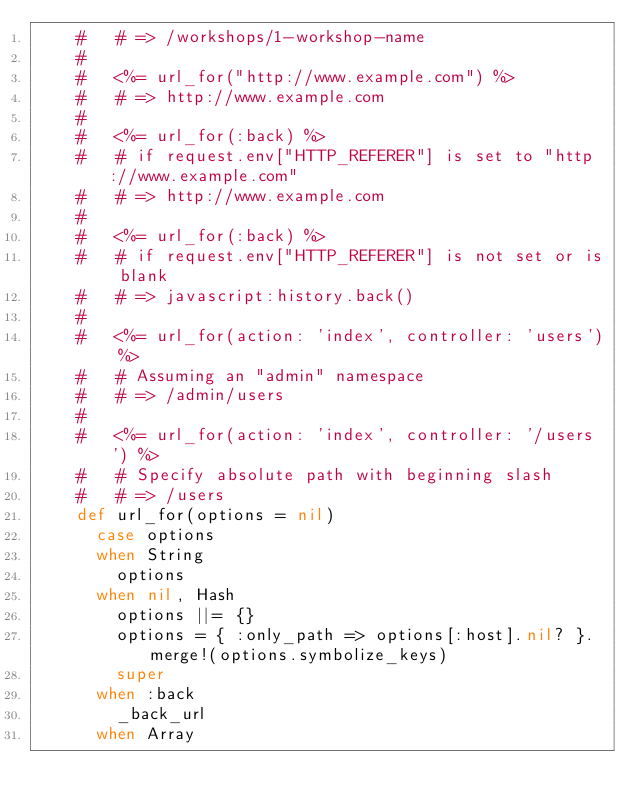Convert code to text. <code><loc_0><loc_0><loc_500><loc_500><_Ruby_>    #   # => /workshops/1-workshop-name
    #
    #   <%= url_for("http://www.example.com") %>
    #   # => http://www.example.com
    #
    #   <%= url_for(:back) %>
    #   # if request.env["HTTP_REFERER"] is set to "http://www.example.com"
    #   # => http://www.example.com
    #
    #   <%= url_for(:back) %>
    #   # if request.env["HTTP_REFERER"] is not set or is blank
    #   # => javascript:history.back()
    #
    #   <%= url_for(action: 'index', controller: 'users') %>
    #   # Assuming an "admin" namespace
    #   # => /admin/users
    #
    #   <%= url_for(action: 'index', controller: '/users') %>
    #   # Specify absolute path with beginning slash
    #   # => /users
    def url_for(options = nil)
      case options
      when String
        options
      when nil, Hash
        options ||= {}
        options = { :only_path => options[:host].nil? }.merge!(options.symbolize_keys)
        super
      when :back
        _back_url
      when Array</code> 